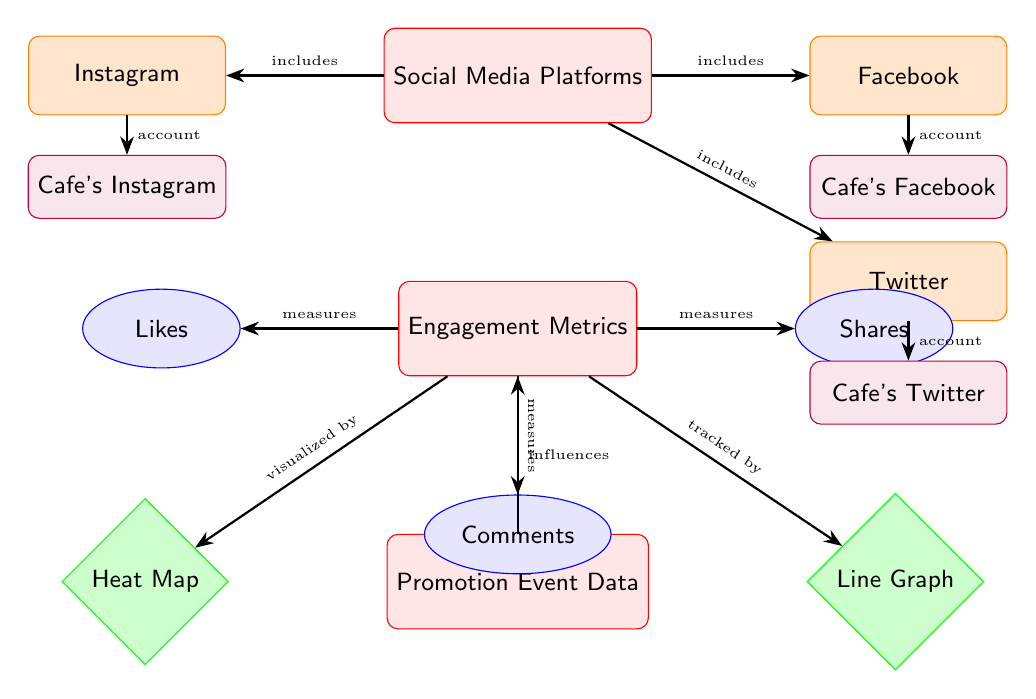What are the social media platforms listed in the diagram? The diagram explicitly shows three social media platforms: Instagram, Facebook, and Twitter. These are represented as nodes stemming from the "Social Media Platforms" node.
Answer: Instagram, Facebook, Twitter How many engagement metrics are depicted in the diagram? The diagram shows three engagement metrics which are connected to the "Engagement Metrics" node. These metrics are Likes, Shares, and Comments.
Answer: Three What influences the engagement metrics according to the diagram? The diagram indicates that "Promotion Event Data" influences the "Engagement Metrics". This is shown by the arrow pointing from "Promotion Event Data" to "Engagement Metrics".
Answer: Promotion Event Data Which visualizations are used to represent engagement metrics in the diagram? The diagram specifies two types of visualizations that represent engagement metrics: Heat Map and Line Graph. These are located next to the "Engagement Metrics" node, connected by arrows.
Answer: Heat Map, Line Graph How is "Likes" measured according to the diagram? According to the diagram, "Likes" are one of the three metrics that are measured by the "Engagement Metrics" node, indicating a direct connection.
Answer: Measured What is the relationship between "Engagement Metrics" and "Promotion Event Data"? "Promotion Event Data" affects "Engagement Metrics", as shown by the arrow pointing from "Promotion Event Data" to "Engagement Metrics", representing that promotional activities have a direct impact on engagement levels.
Answer: Influences Which account is associated with Instagram in the diagram? The diagram specifies that "Cafe's Instagram" is the account corresponding to the Instagram platform, indicated by the directing arrow from "Instagram" to "Cafe's Instagram".
Answer: Cafe's Instagram What type of node is "Shares"? The "Shares" node is classified as a metric, specifically represented by an ellipse in the diagram, showing its relationship with the "Engagement Metrics" node.
Answer: Metric 